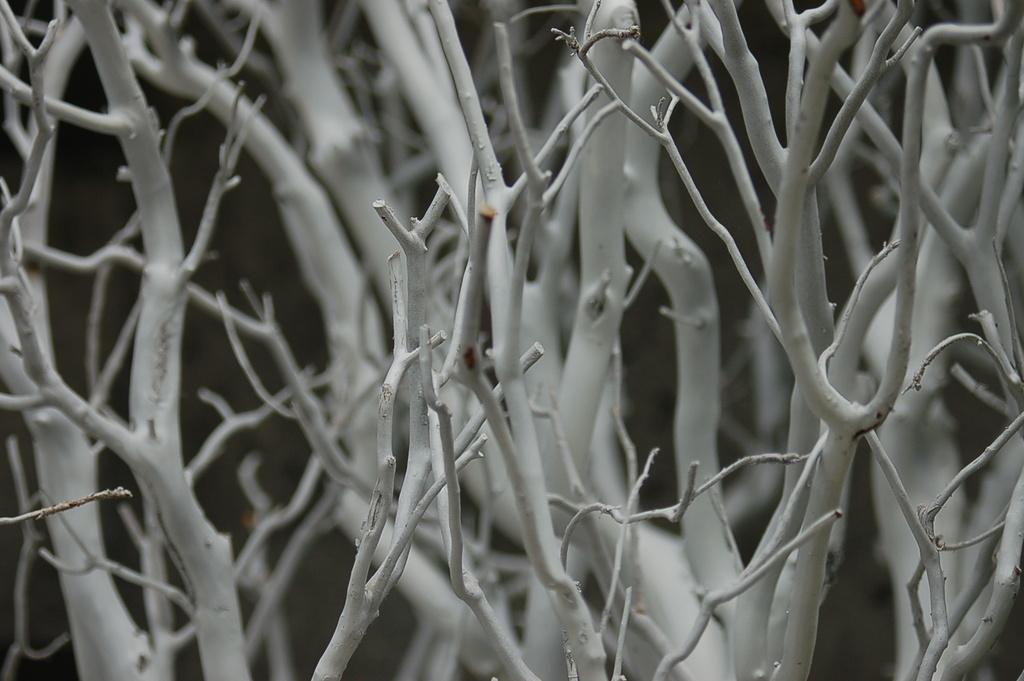What type of plant material is present in the image? There are dry stems of a tree in the image. Can you describe the condition of the plant material? The stems are dry in the image. How many hands are visible in the image? There are no hands present in the image; it only features dry stems of a tree. 